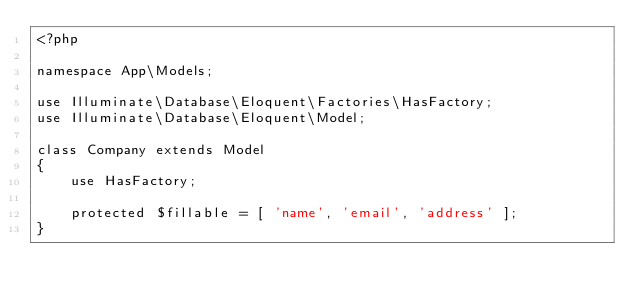Convert code to text. <code><loc_0><loc_0><loc_500><loc_500><_PHP_><?php
 
namespace App\Models;
 
use Illuminate\Database\Eloquent\Factories\HasFactory;
use Illuminate\Database\Eloquent\Model;
 
class Company extends Model
{
    use HasFactory;
 
    protected $fillable = [ 'name', 'email', 'address' ];
}</code> 